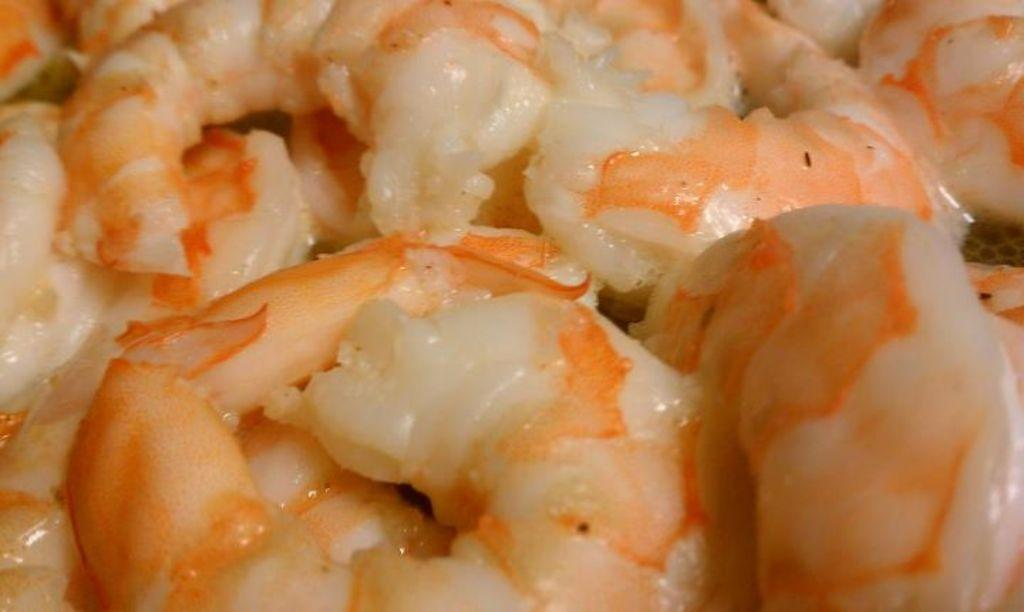What can be seen in the image? There is food visible in the image. What type of beast can be seen interacting with the food in the image? There is no beast present in the image; it only features food. What sense is being utilized by the food in the image? Food does not have senses, as it is an inanimate object. 